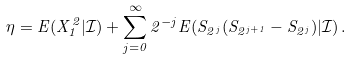Convert formula to latex. <formula><loc_0><loc_0><loc_500><loc_500>\eta = E ( X _ { 1 } ^ { 2 } | \mathcal { I } ) + \sum _ { j = 0 } ^ { \infty } 2 ^ { - j } E ( S _ { 2 ^ { j } } ( S _ { 2 ^ { j + 1 } } - S _ { 2 ^ { j } } ) | \mathcal { I } ) \, .</formula> 